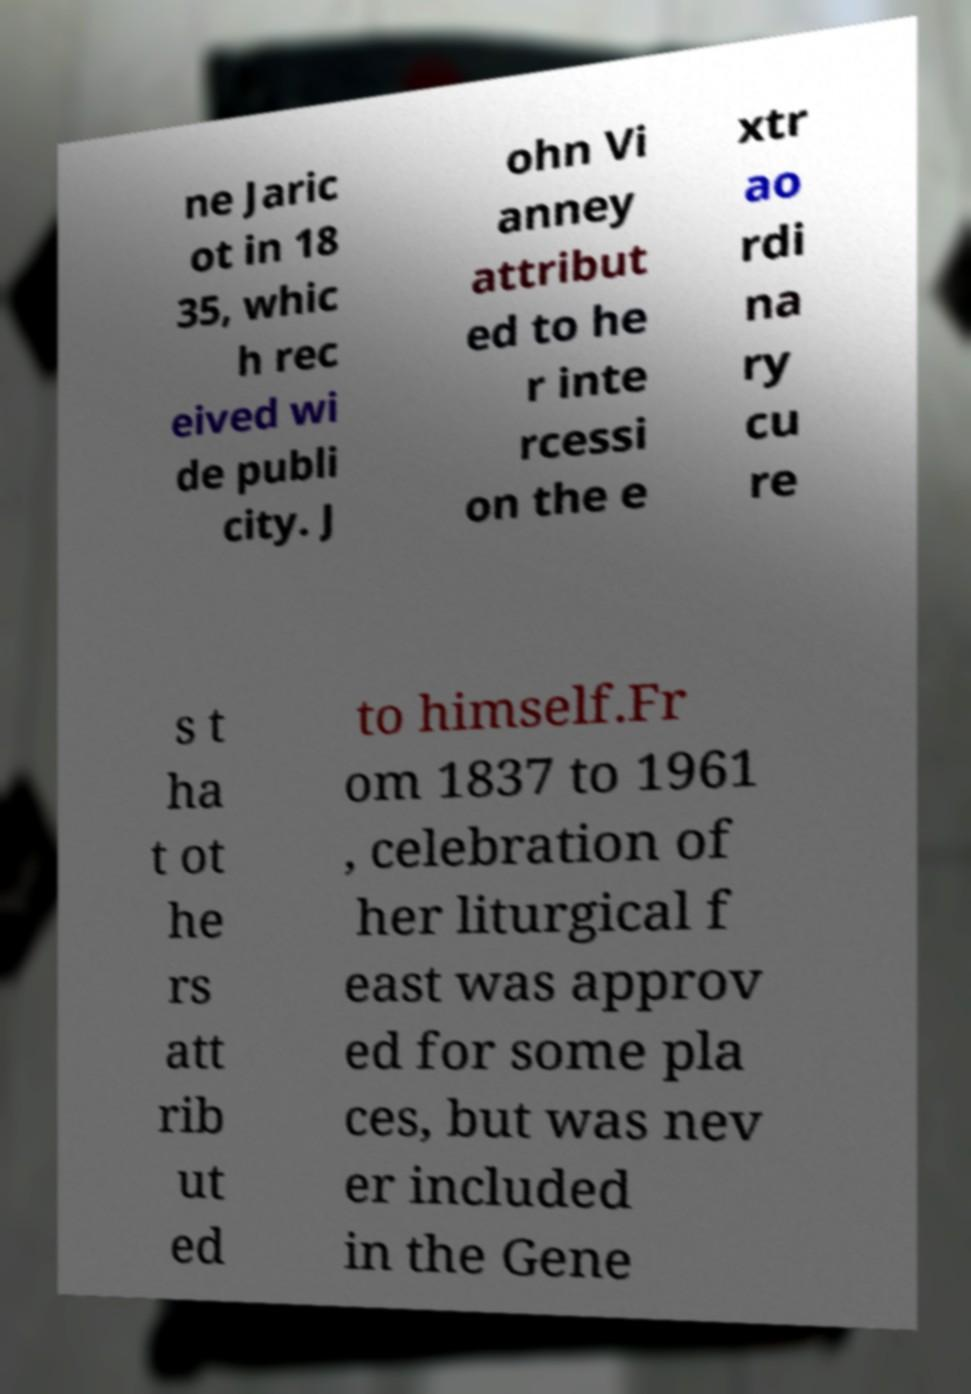Can you read and provide the text displayed in the image?This photo seems to have some interesting text. Can you extract and type it out for me? ne Jaric ot in 18 35, whic h rec eived wi de publi city. J ohn Vi anney attribut ed to he r inte rcessi on the e xtr ao rdi na ry cu re s t ha t ot he rs att rib ut ed to himself.Fr om 1837 to 1961 , celebration of her liturgical f east was approv ed for some pla ces, but was nev er included in the Gene 